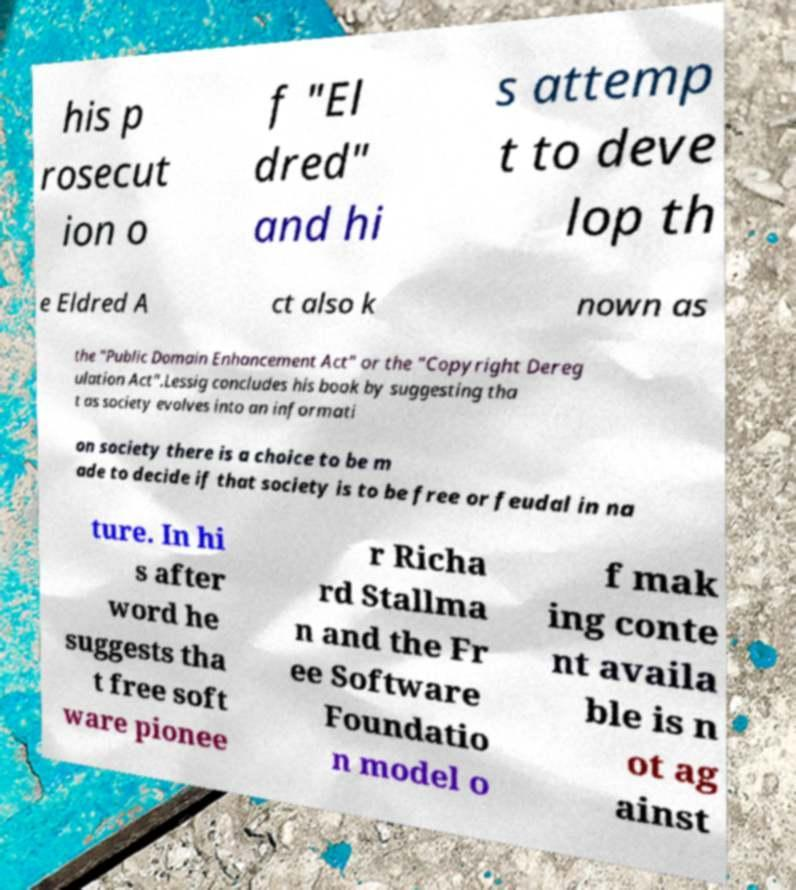For documentation purposes, I need the text within this image transcribed. Could you provide that? his p rosecut ion o f "El dred" and hi s attemp t to deve lop th e Eldred A ct also k nown as the "Public Domain Enhancement Act" or the "Copyright Dereg ulation Act".Lessig concludes his book by suggesting tha t as society evolves into an informati on society there is a choice to be m ade to decide if that society is to be free or feudal in na ture. In hi s after word he suggests tha t free soft ware pionee r Richa rd Stallma n and the Fr ee Software Foundatio n model o f mak ing conte nt availa ble is n ot ag ainst 